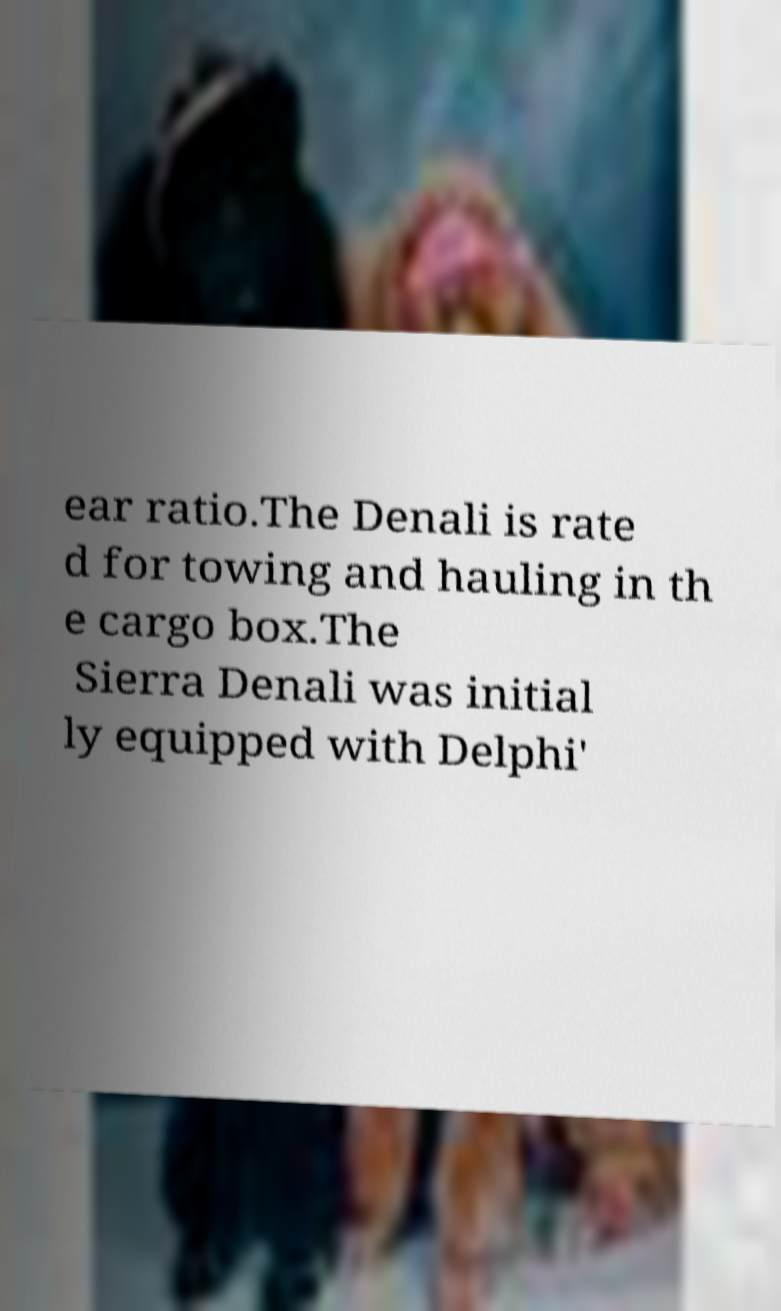Could you extract and type out the text from this image? ear ratio.The Denali is rate d for towing and hauling in th e cargo box.The Sierra Denali was initial ly equipped with Delphi' 